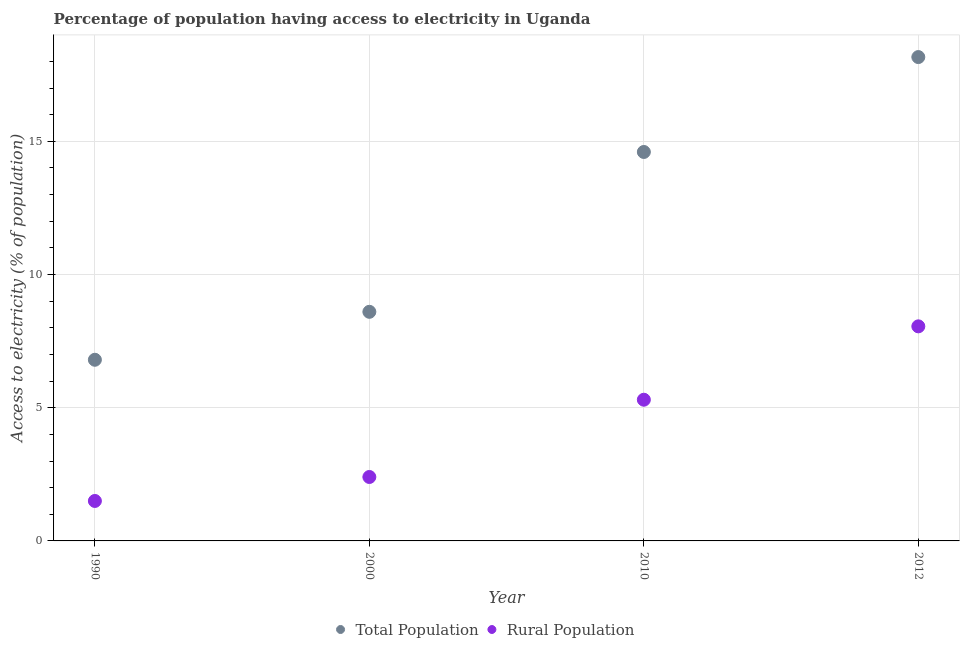What is the percentage of rural population having access to electricity in 2010?
Keep it short and to the point. 5.3. Across all years, what is the maximum percentage of rural population having access to electricity?
Provide a short and direct response. 8.05. What is the total percentage of population having access to electricity in the graph?
Make the answer very short. 48.16. What is the difference between the percentage of population having access to electricity in 1990 and that in 2000?
Make the answer very short. -1.8. What is the difference between the percentage of rural population having access to electricity in 2012 and the percentage of population having access to electricity in 1990?
Make the answer very short. 1.25. What is the average percentage of population having access to electricity per year?
Ensure brevity in your answer.  12.04. In the year 2000, what is the difference between the percentage of population having access to electricity and percentage of rural population having access to electricity?
Your response must be concise. 6.2. What is the ratio of the percentage of population having access to electricity in 1990 to that in 2010?
Your response must be concise. 0.47. What is the difference between the highest and the second highest percentage of rural population having access to electricity?
Provide a succinct answer. 2.75. What is the difference between the highest and the lowest percentage of rural population having access to electricity?
Keep it short and to the point. 6.55. Is the percentage of population having access to electricity strictly greater than the percentage of rural population having access to electricity over the years?
Offer a very short reply. Yes. Where does the legend appear in the graph?
Your answer should be very brief. Bottom center. What is the title of the graph?
Your answer should be compact. Percentage of population having access to electricity in Uganda. Does "Rural Population" appear as one of the legend labels in the graph?
Your answer should be compact. Yes. What is the label or title of the X-axis?
Ensure brevity in your answer.  Year. What is the label or title of the Y-axis?
Give a very brief answer. Access to electricity (% of population). What is the Access to electricity (% of population) in Total Population in 1990?
Offer a terse response. 6.8. What is the Access to electricity (% of population) in Total Population in 2000?
Your answer should be very brief. 8.6. What is the Access to electricity (% of population) in Rural Population in 2000?
Provide a short and direct response. 2.4. What is the Access to electricity (% of population) of Total Population in 2012?
Make the answer very short. 18.16. What is the Access to electricity (% of population) in Rural Population in 2012?
Provide a short and direct response. 8.05. Across all years, what is the maximum Access to electricity (% of population) in Total Population?
Your response must be concise. 18.16. Across all years, what is the maximum Access to electricity (% of population) in Rural Population?
Your response must be concise. 8.05. Across all years, what is the minimum Access to electricity (% of population) of Total Population?
Your answer should be very brief. 6.8. Across all years, what is the minimum Access to electricity (% of population) of Rural Population?
Provide a short and direct response. 1.5. What is the total Access to electricity (% of population) of Total Population in the graph?
Keep it short and to the point. 48.16. What is the total Access to electricity (% of population) of Rural Population in the graph?
Your answer should be very brief. 17.25. What is the difference between the Access to electricity (% of population) in Rural Population in 1990 and that in 2000?
Your response must be concise. -0.9. What is the difference between the Access to electricity (% of population) in Total Population in 1990 and that in 2010?
Give a very brief answer. -7.8. What is the difference between the Access to electricity (% of population) of Rural Population in 1990 and that in 2010?
Your answer should be very brief. -3.8. What is the difference between the Access to electricity (% of population) of Total Population in 1990 and that in 2012?
Give a very brief answer. -11.36. What is the difference between the Access to electricity (% of population) in Rural Population in 1990 and that in 2012?
Give a very brief answer. -6.55. What is the difference between the Access to electricity (% of population) in Rural Population in 2000 and that in 2010?
Offer a terse response. -2.9. What is the difference between the Access to electricity (% of population) in Total Population in 2000 and that in 2012?
Provide a short and direct response. -9.56. What is the difference between the Access to electricity (% of population) in Rural Population in 2000 and that in 2012?
Offer a terse response. -5.65. What is the difference between the Access to electricity (% of population) of Total Population in 2010 and that in 2012?
Give a very brief answer. -3.56. What is the difference between the Access to electricity (% of population) in Rural Population in 2010 and that in 2012?
Keep it short and to the point. -2.75. What is the difference between the Access to electricity (% of population) of Total Population in 1990 and the Access to electricity (% of population) of Rural Population in 2010?
Your answer should be compact. 1.5. What is the difference between the Access to electricity (% of population) in Total Population in 1990 and the Access to electricity (% of population) in Rural Population in 2012?
Your answer should be compact. -1.25. What is the difference between the Access to electricity (% of population) of Total Population in 2000 and the Access to electricity (% of population) of Rural Population in 2012?
Offer a terse response. 0.55. What is the difference between the Access to electricity (% of population) of Total Population in 2010 and the Access to electricity (% of population) of Rural Population in 2012?
Your answer should be compact. 6.55. What is the average Access to electricity (% of population) of Total Population per year?
Offer a very short reply. 12.04. What is the average Access to electricity (% of population) in Rural Population per year?
Keep it short and to the point. 4.31. In the year 2000, what is the difference between the Access to electricity (% of population) of Total Population and Access to electricity (% of population) of Rural Population?
Offer a very short reply. 6.2. In the year 2010, what is the difference between the Access to electricity (% of population) of Total Population and Access to electricity (% of population) of Rural Population?
Give a very brief answer. 9.3. In the year 2012, what is the difference between the Access to electricity (% of population) of Total Population and Access to electricity (% of population) of Rural Population?
Provide a short and direct response. 10.11. What is the ratio of the Access to electricity (% of population) of Total Population in 1990 to that in 2000?
Make the answer very short. 0.79. What is the ratio of the Access to electricity (% of population) of Rural Population in 1990 to that in 2000?
Ensure brevity in your answer.  0.62. What is the ratio of the Access to electricity (% of population) of Total Population in 1990 to that in 2010?
Ensure brevity in your answer.  0.47. What is the ratio of the Access to electricity (% of population) in Rural Population in 1990 to that in 2010?
Offer a terse response. 0.28. What is the ratio of the Access to electricity (% of population) of Total Population in 1990 to that in 2012?
Provide a succinct answer. 0.37. What is the ratio of the Access to electricity (% of population) in Rural Population in 1990 to that in 2012?
Your answer should be compact. 0.19. What is the ratio of the Access to electricity (% of population) in Total Population in 2000 to that in 2010?
Your response must be concise. 0.59. What is the ratio of the Access to electricity (% of population) of Rural Population in 2000 to that in 2010?
Provide a succinct answer. 0.45. What is the ratio of the Access to electricity (% of population) of Total Population in 2000 to that in 2012?
Ensure brevity in your answer.  0.47. What is the ratio of the Access to electricity (% of population) in Rural Population in 2000 to that in 2012?
Make the answer very short. 0.3. What is the ratio of the Access to electricity (% of population) in Total Population in 2010 to that in 2012?
Your response must be concise. 0.8. What is the ratio of the Access to electricity (% of population) of Rural Population in 2010 to that in 2012?
Your answer should be compact. 0.66. What is the difference between the highest and the second highest Access to electricity (% of population) of Total Population?
Your response must be concise. 3.56. What is the difference between the highest and the second highest Access to electricity (% of population) in Rural Population?
Provide a short and direct response. 2.75. What is the difference between the highest and the lowest Access to electricity (% of population) of Total Population?
Offer a very short reply. 11.36. What is the difference between the highest and the lowest Access to electricity (% of population) in Rural Population?
Provide a succinct answer. 6.55. 